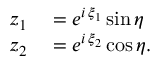Convert formula to latex. <formula><loc_0><loc_0><loc_500><loc_500>\begin{array} { r l } { z _ { 1 } } & = e ^ { i \, \xi _ { 1 } } \sin \eta } \\ { z _ { 2 } } & = e ^ { i \, \xi _ { 2 } } \cos \eta . } \end{array}</formula> 